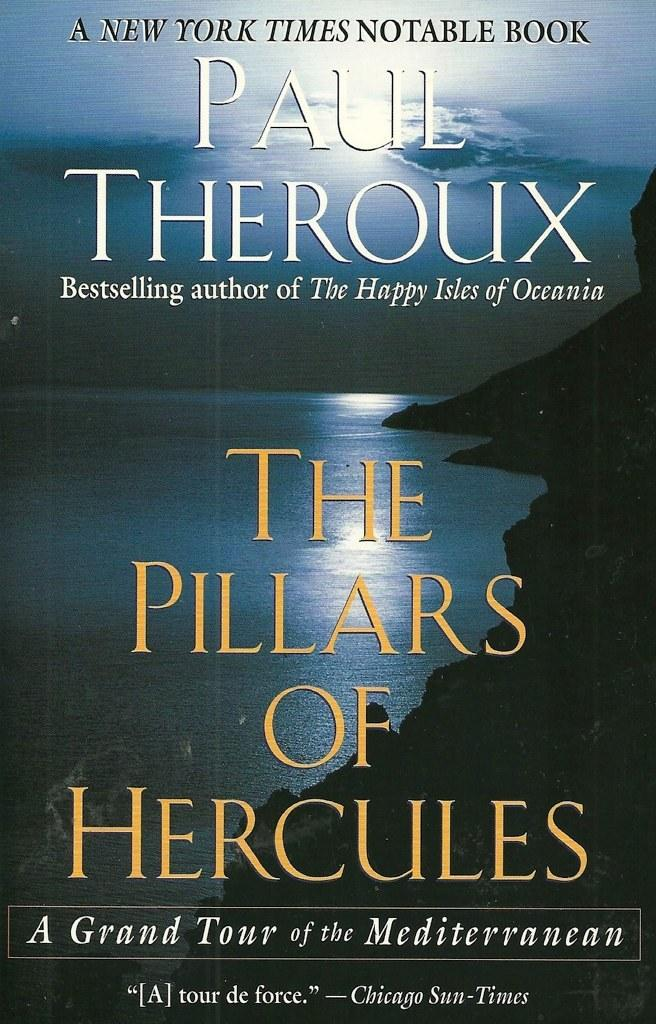<image>
Render a clear and concise summary of the photo. A book by Paul Theroux shows the shore. 